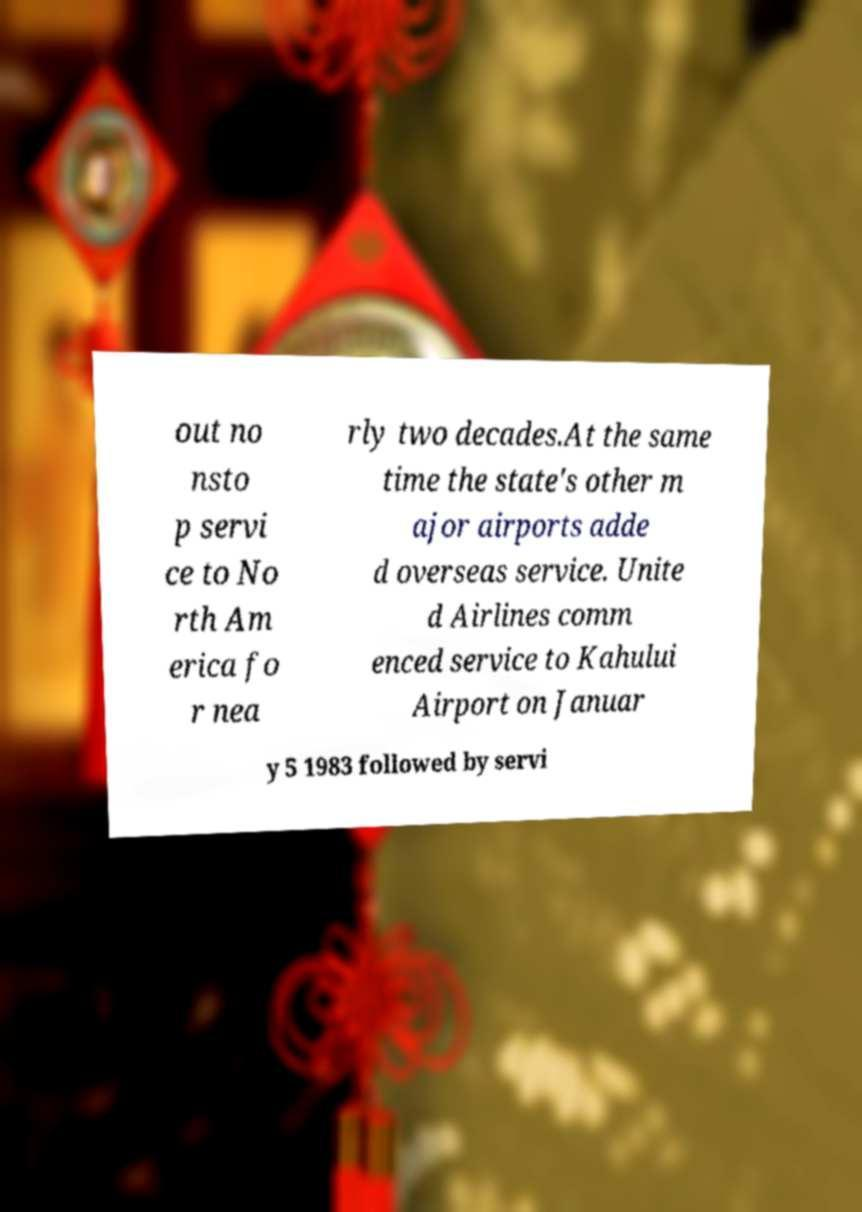Can you accurately transcribe the text from the provided image for me? out no nsto p servi ce to No rth Am erica fo r nea rly two decades.At the same time the state's other m ajor airports adde d overseas service. Unite d Airlines comm enced service to Kahului Airport on Januar y 5 1983 followed by servi 